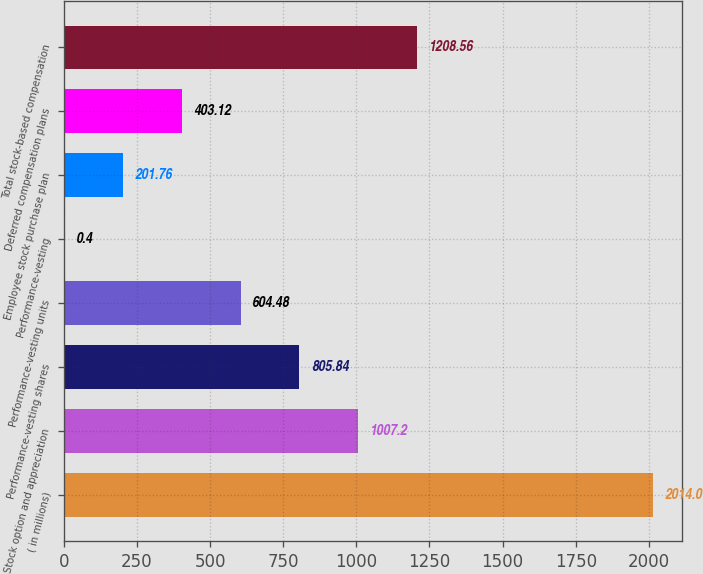Convert chart. <chart><loc_0><loc_0><loc_500><loc_500><bar_chart><fcel>( in millions)<fcel>Stock option and appreciation<fcel>Performance-vesting shares<fcel>Performance-vesting units<fcel>Performance-vesting<fcel>Employee stock purchase plan<fcel>Deferred compensation plans<fcel>Total stock-based compensation<nl><fcel>2014<fcel>1007.2<fcel>805.84<fcel>604.48<fcel>0.4<fcel>201.76<fcel>403.12<fcel>1208.56<nl></chart> 